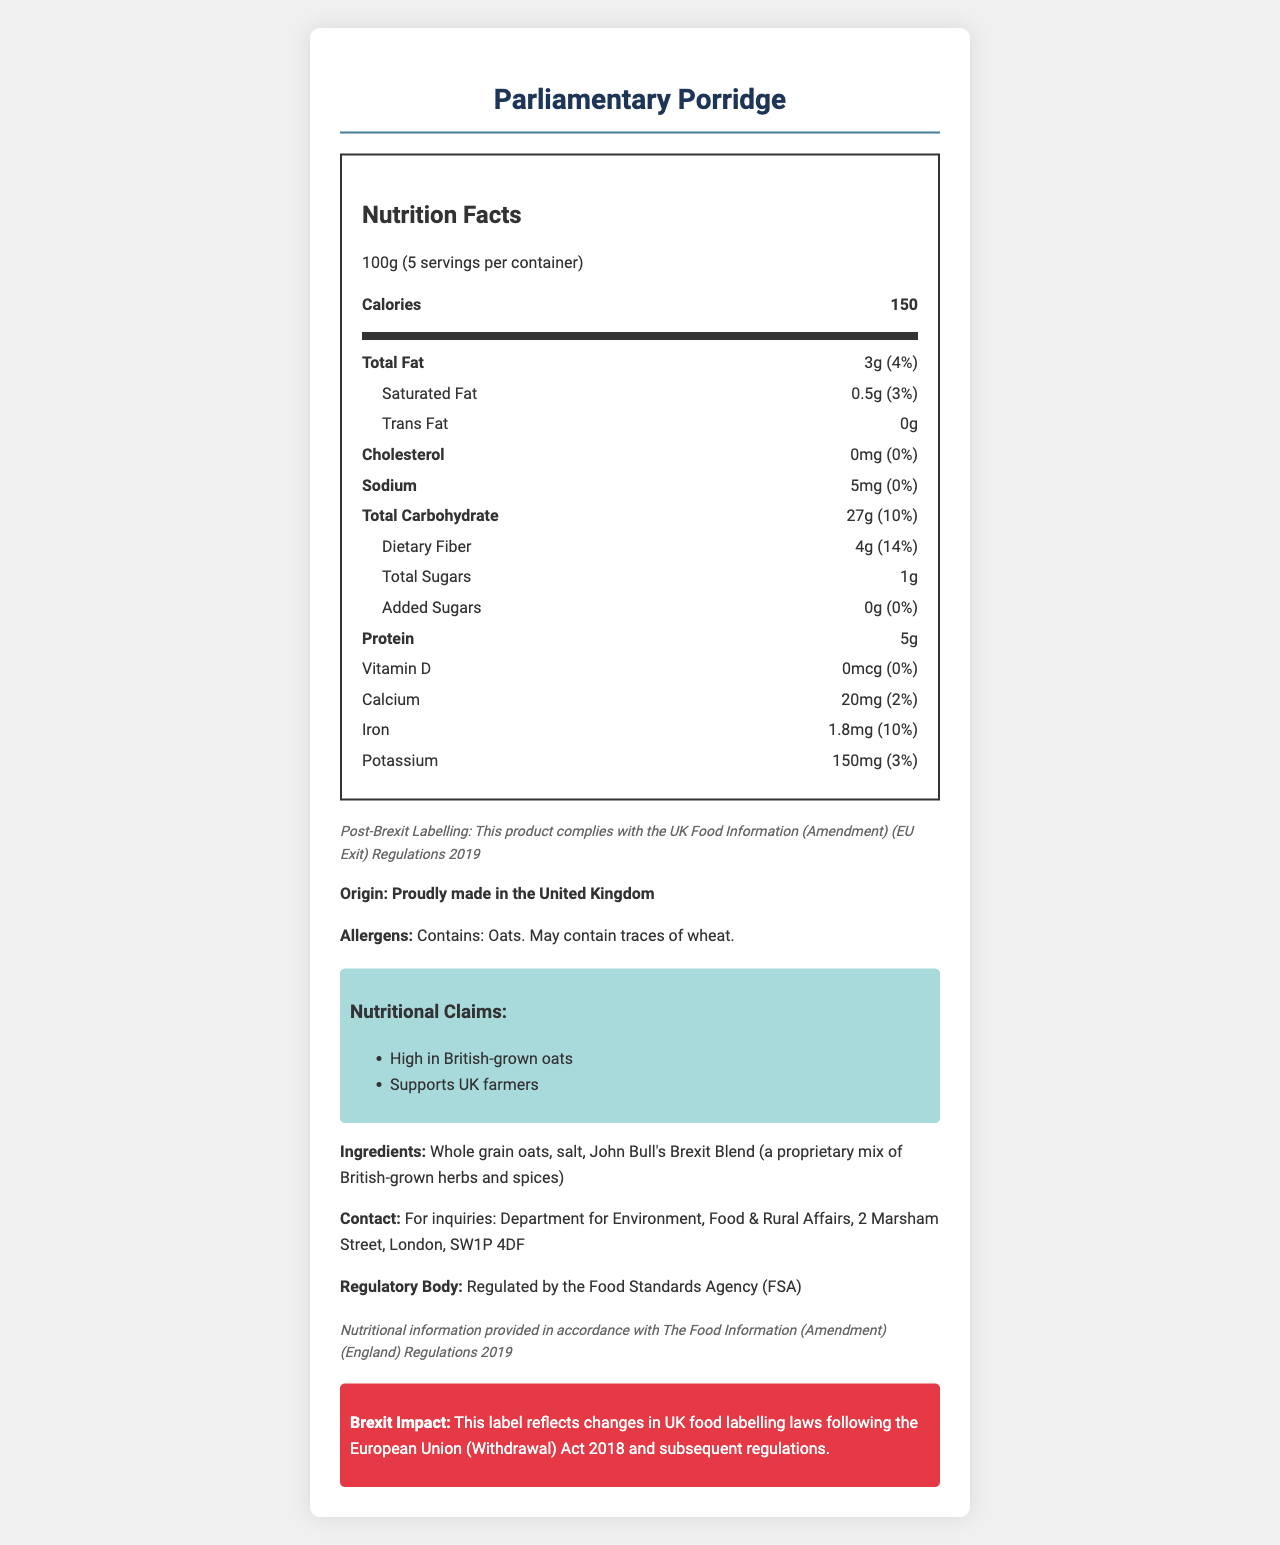how many calories are in one serving? It is clearly stated next to "Calories" in the Nutrition Facts section.
Answer: 150 calories what is the serving size of Parliamentary Porridge? The serving size is listed under the product name at the top of the Nutrition Facts section.
Answer: 100g what is the total dietary fiber in one serving? The amount of dietary fiber is listed under Total Carbohydrate in the Nutrition Facts section.
Answer: 4g what percentage of the daily value of iron does one serving provide? The daily value percentage for iron is listed in the Nutrition Facts section.
Answer: 10% where is this product made? The origin statement clearly states "Proudly made in the United Kingdom."
Answer: United Kingdom which UK regulatory body oversees the compliance of this product? A. Food and Drug Administration (FDA) B. European Food Safety Authority (EFSA) C. Food Standards Agency (FSA) The document states that the product is regulated by the Food Standards Agency (FSA).
Answer: C what are the allergens in this product? The allergens warning section under the origin statement lists "Contains: Oats. May contain traces of wheat."
Answer: Oats, may contain traces of wheat which nutritional claim is no longer allowed? A. High in British-grown oats B. Supports UK farmers C. EU Protected Geographical Indication (PGI) D. Contains whole grain oats The document lists EU Protected Geographical Indication (PGI) in the banned nutritional claims section.
Answer: C are there any added sugars in this product? The Nutrition Facts section lists "0g" for added sugars.
Answer: No what is the total amount of fat in one serving? The total fat amount is listed under Total Fat in the Nutrition Facts section.
Answer: 3g what is the contact information for inquiries related to the product? The contact information is provided towards the end of the document.
Answer: Department for Environment, Food & Rural Affairs, 2 Marsham Street, London, SW1P 4DF is there any cholesterol in this product? The Nutrition Facts section lists "0mg" for cholesterol.
Answer: No summarize the main idea of the document. The document lists the nutritional facts, serving size, allergens, new and banned nutritional claims, and regulatory and contact information, along with statements highlighting compliance with the changes in UK food labelling laws post-Brexit.
Answer: The document provides detailed nutritional information about Parliamentary Porridge, a product made in the UK, including changes in labelling laws post-Brexit and compliance with UK regulations. can we determine the cost of the product from the document? The document does not provide any information regarding the cost of Parliamentary Porridge.
Answer: Not enough information 